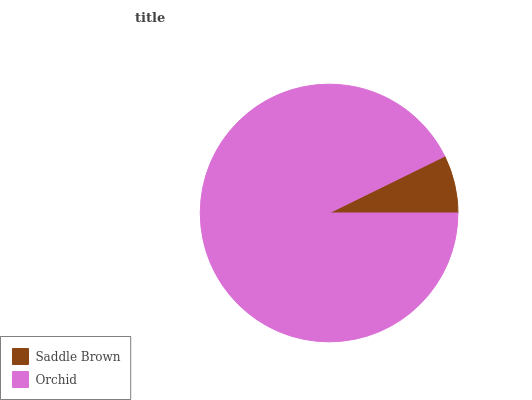Is Saddle Brown the minimum?
Answer yes or no. Yes. Is Orchid the maximum?
Answer yes or no. Yes. Is Orchid the minimum?
Answer yes or no. No. Is Orchid greater than Saddle Brown?
Answer yes or no. Yes. Is Saddle Brown less than Orchid?
Answer yes or no. Yes. Is Saddle Brown greater than Orchid?
Answer yes or no. No. Is Orchid less than Saddle Brown?
Answer yes or no. No. Is Orchid the high median?
Answer yes or no. Yes. Is Saddle Brown the low median?
Answer yes or no. Yes. Is Saddle Brown the high median?
Answer yes or no. No. Is Orchid the low median?
Answer yes or no. No. 